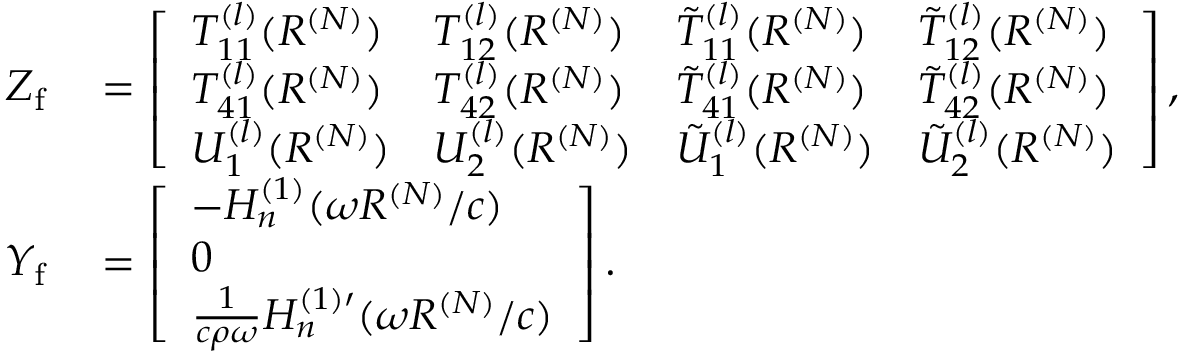<formula> <loc_0><loc_0><loc_500><loc_500>\begin{array} { r l } { Z _ { f } } & = \left [ \begin{array} { l l l l } { T _ { 1 1 } ^ { ( l ) } ( R ^ { ( N ) } ) } & { T _ { 1 2 } ^ { ( l ) } ( R ^ { ( N ) } ) } & { \tilde { T } _ { 1 1 } ^ { ( l ) } ( R ^ { ( N ) } ) } & { \tilde { T } _ { 1 2 } ^ { ( l ) } ( R ^ { ( N ) } ) } \\ { T _ { 4 1 } ^ { ( l ) } ( R ^ { ( N ) } ) } & { T _ { 4 2 } ^ { ( l ) } ( R ^ { ( N ) } ) } & { \tilde { T } _ { 4 1 } ^ { ( l ) } ( R ^ { ( N ) } ) } & { \tilde { T } _ { 4 2 } ^ { ( l ) } ( R ^ { ( N ) } ) } \\ { U _ { 1 } ^ { ( l ) } ( R ^ { ( N ) } ) } & { U _ { 2 } ^ { ( l ) } ( R ^ { ( N ) } ) } & { \tilde { U } _ { 1 } ^ { ( l ) } ( R ^ { ( N ) } ) } & { \tilde { U } _ { 2 } ^ { ( l ) } ( R ^ { ( N ) } ) } \end{array} \right ] , } \\ { Y _ { f } } & = \left [ \begin{array} { l } { - H _ { n } ^ { ( 1 ) } ( \omega R ^ { ( N ) } / c ) } \\ { 0 } \\ { \frac { 1 } { c \rho \omega } H _ { n } ^ { ( 1 ) \prime } ( \omega R ^ { ( N ) } / c ) } \end{array} \right ] . } \end{array}</formula> 